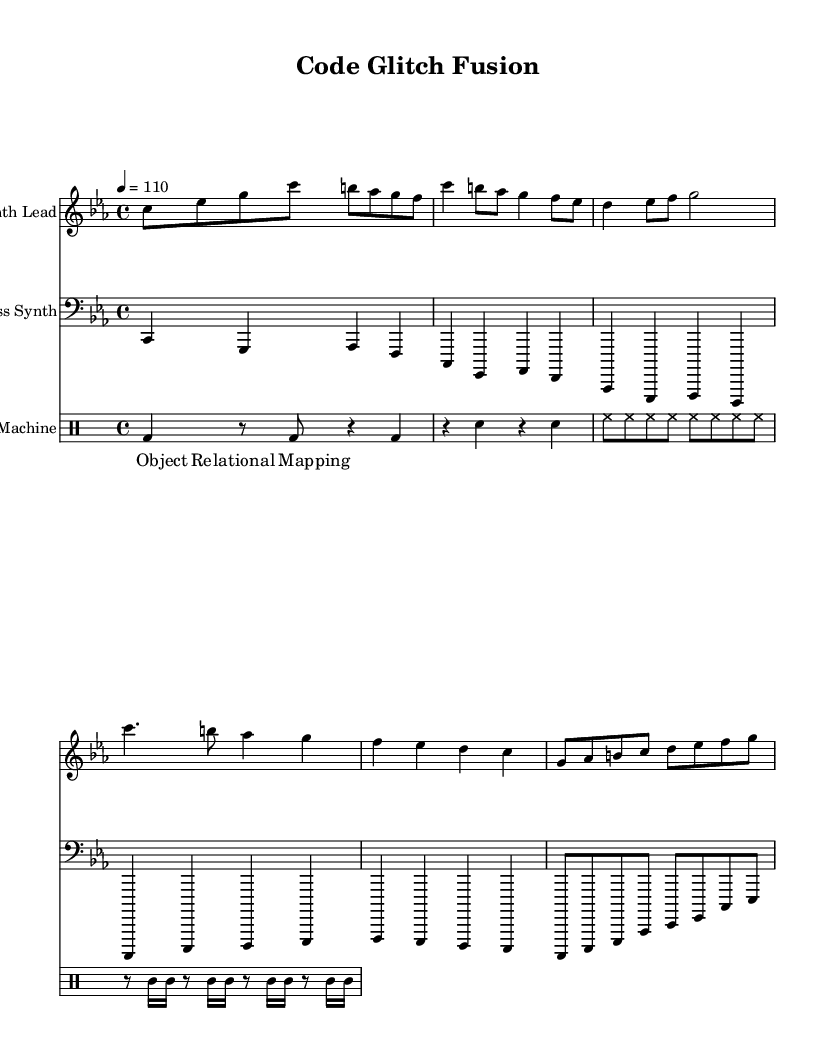What is the key signature of this music? The key signature is indicated at the beginning of the staff and shows that this piece is in C minor, which has three flats: B flat, E flat, and A flat.
Answer: C minor What is the time signature of the piece? The time signature, found at the beginning of the music, is 4/4, meaning there are four beats in each measure, and the quarter note gets one beat.
Answer: 4/4 What is the tempo indication? The tempo is also provided at the start of the score, indicating the piece should be played at a speed of 110 beats per minute, which is often referred to as "moderately fast."
Answer: 110 How many measures are in the synthesizer lead part? To find the number of measures in the synthesizer lead, count each bar in the notation. There are a total of six measures represented visually.
Answer: 6 What vocal sample is used in the piece? The lyrics, which are part of the vocal samples in the piece, state "Object Relational Mapping." They are located above the bass staff in the lyric mode section.
Answer: Object Relational Mapping What kind of drum pattern is employed in this composition? The drum pattern follows a typical electronic rhythm, characterized by a bass drum (bd) on the beats and snares (sn) on the backbeats, along with hi-hats (hh) and toms, creating a common electronic music feel.
Answer: Electronic rhythm What is the function of the 'bass synth' in this track? The bass synth provides the harmonic foundation of the piece, supporting the melody by playing lower pitched notes in a looped, repetitive sequence characteristic of glitch-hop music.
Answer: Harmonic foundation 